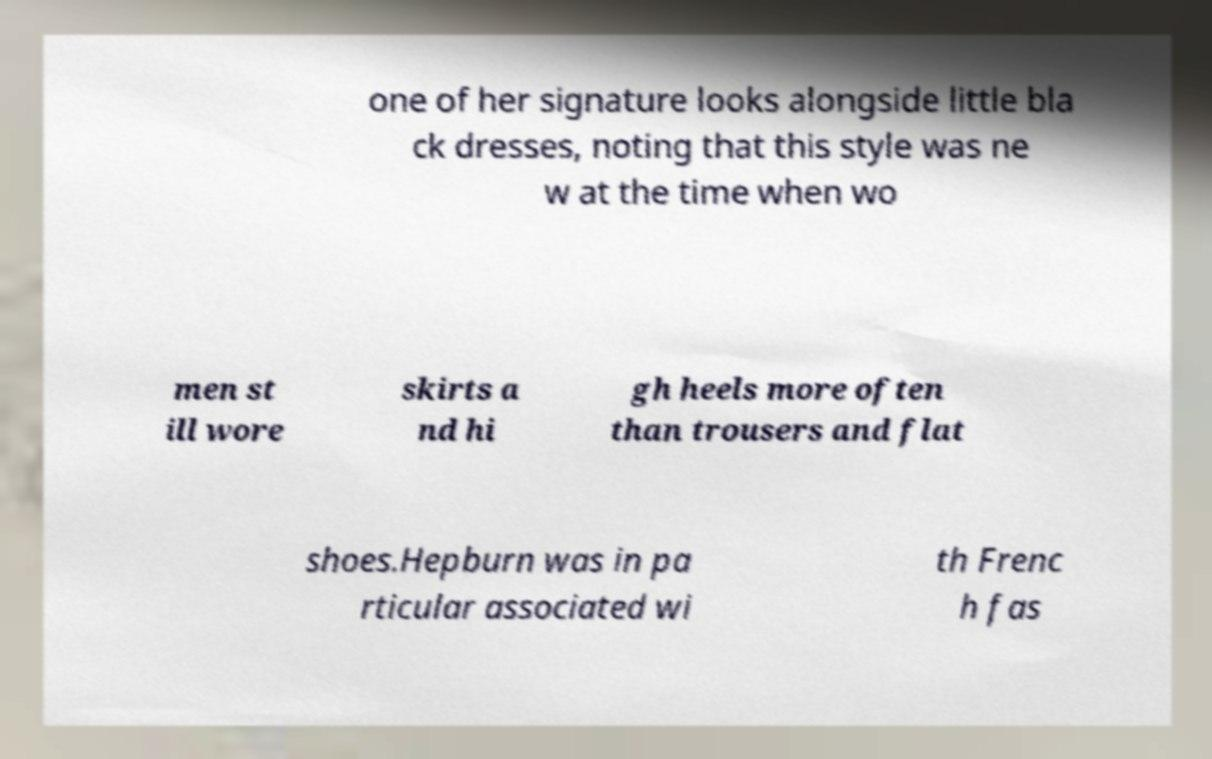Can you read and provide the text displayed in the image?This photo seems to have some interesting text. Can you extract and type it out for me? one of her signature looks alongside little bla ck dresses, noting that this style was ne w at the time when wo men st ill wore skirts a nd hi gh heels more often than trousers and flat shoes.Hepburn was in pa rticular associated wi th Frenc h fas 